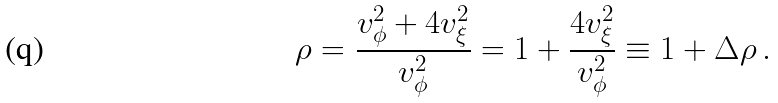Convert formula to latex. <formula><loc_0><loc_0><loc_500><loc_500>\rho = \frac { v _ { \phi } ^ { 2 } + 4 v _ { \xi } ^ { 2 } } { v _ { \phi } ^ { 2 } } = 1 + \frac { 4 v _ { \xi } ^ { 2 } } { v _ { \phi } ^ { 2 } } \equiv 1 + \Delta \rho \, .</formula> 